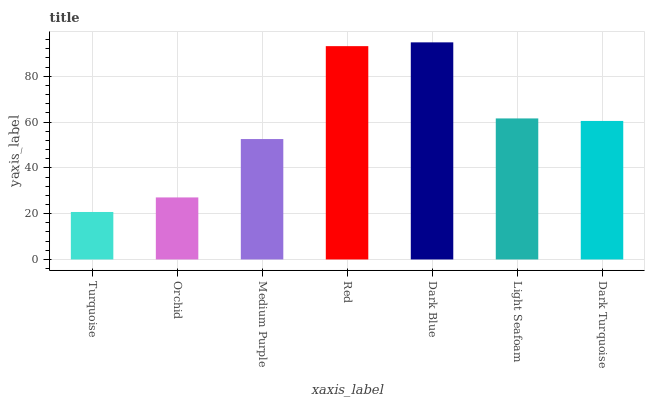Is Turquoise the minimum?
Answer yes or no. Yes. Is Dark Blue the maximum?
Answer yes or no. Yes. Is Orchid the minimum?
Answer yes or no. No. Is Orchid the maximum?
Answer yes or no. No. Is Orchid greater than Turquoise?
Answer yes or no. Yes. Is Turquoise less than Orchid?
Answer yes or no. Yes. Is Turquoise greater than Orchid?
Answer yes or no. No. Is Orchid less than Turquoise?
Answer yes or no. No. Is Dark Turquoise the high median?
Answer yes or no. Yes. Is Dark Turquoise the low median?
Answer yes or no. Yes. Is Orchid the high median?
Answer yes or no. No. Is Dark Blue the low median?
Answer yes or no. No. 